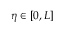Convert formula to latex. <formula><loc_0><loc_0><loc_500><loc_500>\eta \in [ 0 , L ]</formula> 